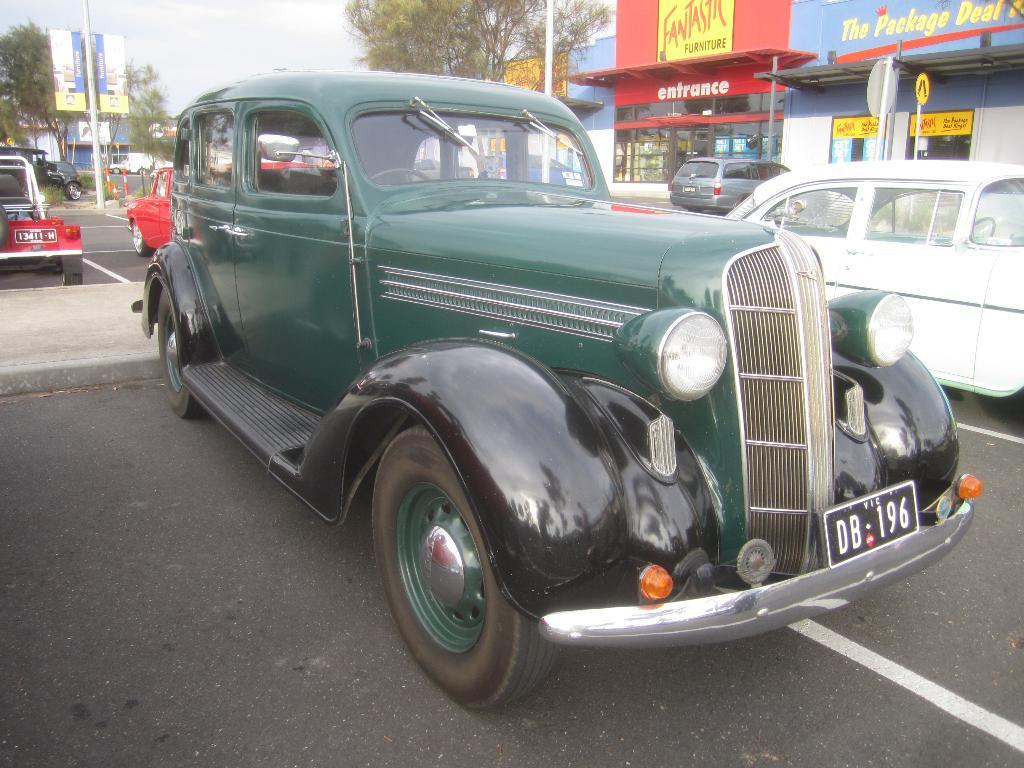What is happening on the road in the image? There are vehicles on the road in the image. Where are the vehicles located in relation to the road? The vehicles are on the road. What can be seen in the background of the image? There are buildings, poles, trees, and hoardings in the background of the image. What rhythm is the bag playing in the image? There is no bag or music present in the image, so it is not possible to determine any rhythm. 